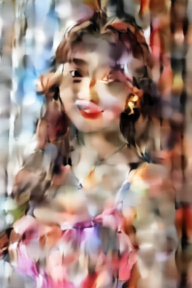描述这幅图片 这幅图片中是一位女士的样子，但是图片经过了特殊处理或者滤镜效果，看起来像是透过一层有纹理或者是湿漉漉的透明表面拍摄的，造成了一种模糊和扭曲的视觉效果。女士似乎有着长发，她的面部特征和表情因为图片效果而显得有些扭曲，不过还是可以看出她在微笑。她穿着带有多彩图案的服装，整体给人一种抽象和艺术化的感觉。 